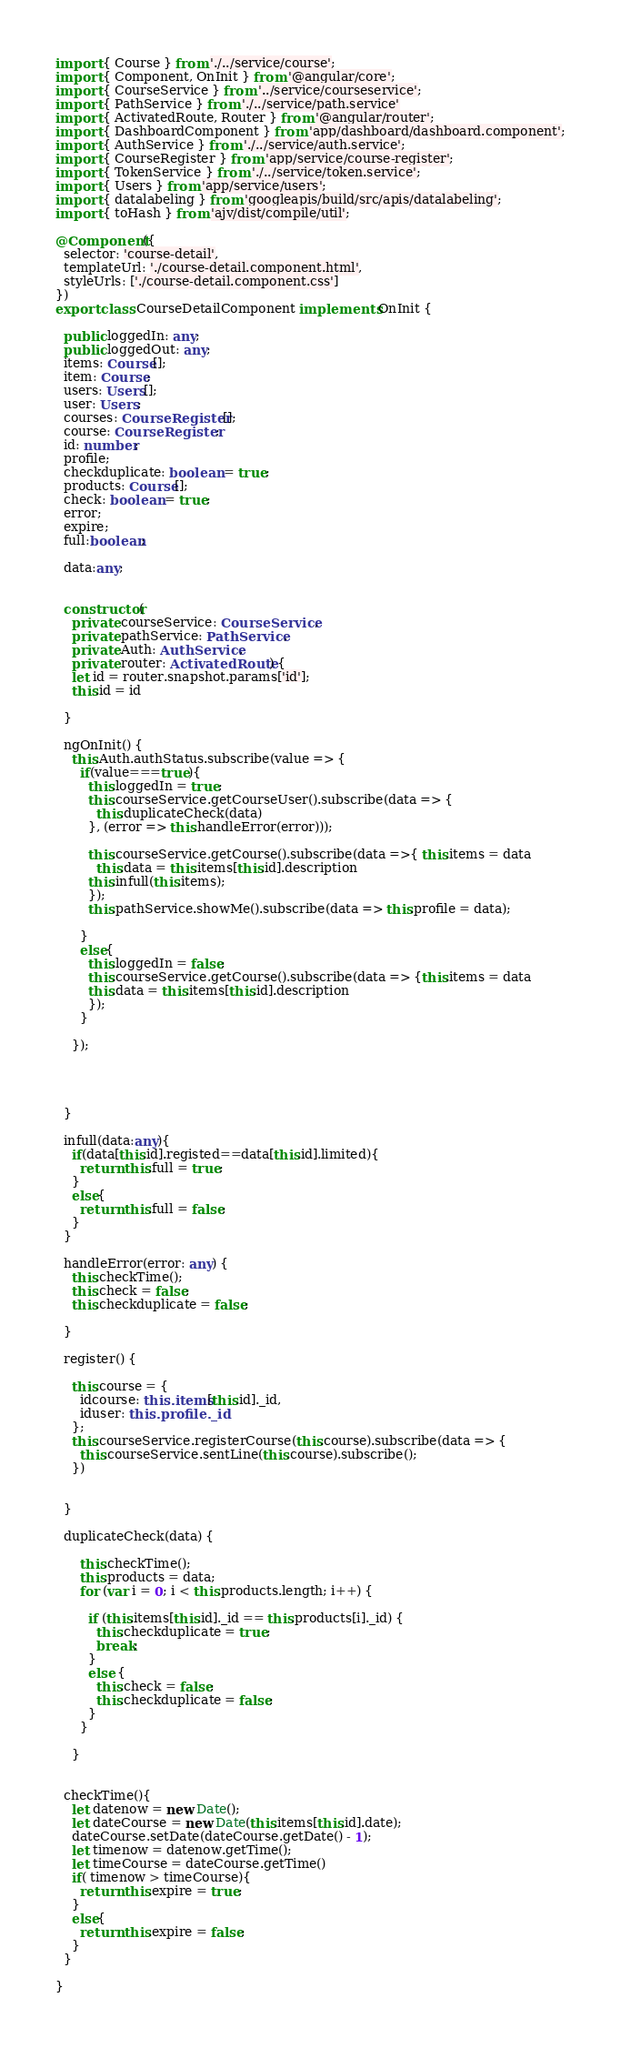<code> <loc_0><loc_0><loc_500><loc_500><_TypeScript_>
import { Course } from './../service/course';
import { Component, OnInit } from '@angular/core';
import { CourseService } from '../service/courseservice';
import { PathService } from './../service/path.service'
import { ActivatedRoute, Router } from '@angular/router';
import { DashboardComponent } from 'app/dashboard/dashboard.component';
import { AuthService } from './../service/auth.service';
import { CourseRegister } from 'app/service/course-register';
import { TokenService } from './../service/token.service';
import { Users } from 'app/service/users';
import { datalabeling } from 'googleapis/build/src/apis/datalabeling';
import { toHash } from 'ajv/dist/compile/util';

@Component({
  selector: 'course-detail',
  templateUrl: './course-detail.component.html',
  styleUrls: ['./course-detail.component.css']
})
export class CourseDetailComponent implements OnInit {

  public loggedIn: any;
  public loggedOut: any;
  items: Course[];
  item: Course;
  users: Users[];
  user: Users;
  courses: CourseRegister[];
  course: CourseRegister;
  id: number;
  profile;
  checkduplicate: boolean = true;
  products: Course[];
  check: boolean = true;
  error;
  expire;
  full:boolean;
  
  data:any;


  constructor(
    private courseService: CourseService,
    private pathService: PathService,
    private Auth: AuthService,
    private router: ActivatedRoute) {
    let id = router.snapshot.params['id'];
    this.id = id

  }

  ngOnInit() {
    this.Auth.authStatus.subscribe(value => {
      if(value===true){
        this.loggedIn = true;
        this.courseService.getCourseUser().subscribe(data => {
          this.duplicateCheck(data)
        }, (error => this.handleError(error)));
    
        this.courseService.getCourse().subscribe(data =>{ this.items = data
          this.data = this.items[this.id].description
        this.infull(this.items);
        });
        this.pathService.showMe().subscribe(data => this.profile = data);

      }
      else{
        this.loggedIn = false;
        this.courseService.getCourse().subscribe(data => {this.items = data
        this.data = this.items[this.id].description
        });
      }
  
    });
   
  


  }

  infull(data:any){
    if(data[this.id].registed==data[this.id].limited){
      return this.full = true;
    }
    else{
      return this.full = false;
    }
  }

  handleError(error: any) {
    this.checkTime();
    this.check = false;
    this.checkduplicate = false;
 
  }

  register() {

    this.course = {
      idcourse: this.items[this.id]._id,
      iduser: this.profile._id
    };
    this.courseService.registerCourse(this.course).subscribe(data => {
      this.courseService.sentLine(this.course).subscribe();
    })
  

  }

  duplicateCheck(data) {
   
      this.checkTime();
      this.products = data;
      for (var i = 0; i < this.products.length; i++) {

        if (this.items[this.id]._id == this.products[i]._id) {
          this.checkduplicate = true;
          break;
        }
        else {
          this.check = false;
          this.checkduplicate = false;
        }
      }

    }
  

  checkTime(){
    let datenow = new Date();
    let dateCourse = new Date(this.items[this.id].date);
    dateCourse.setDate(dateCourse.getDate() - 1);
    let timenow = datenow.getTime();
    let timeCourse = dateCourse.getTime()
    if( timenow > timeCourse){
      return this.expire = true;
    }
    else{
      return this.expire = false;
    }
  }

}
</code> 